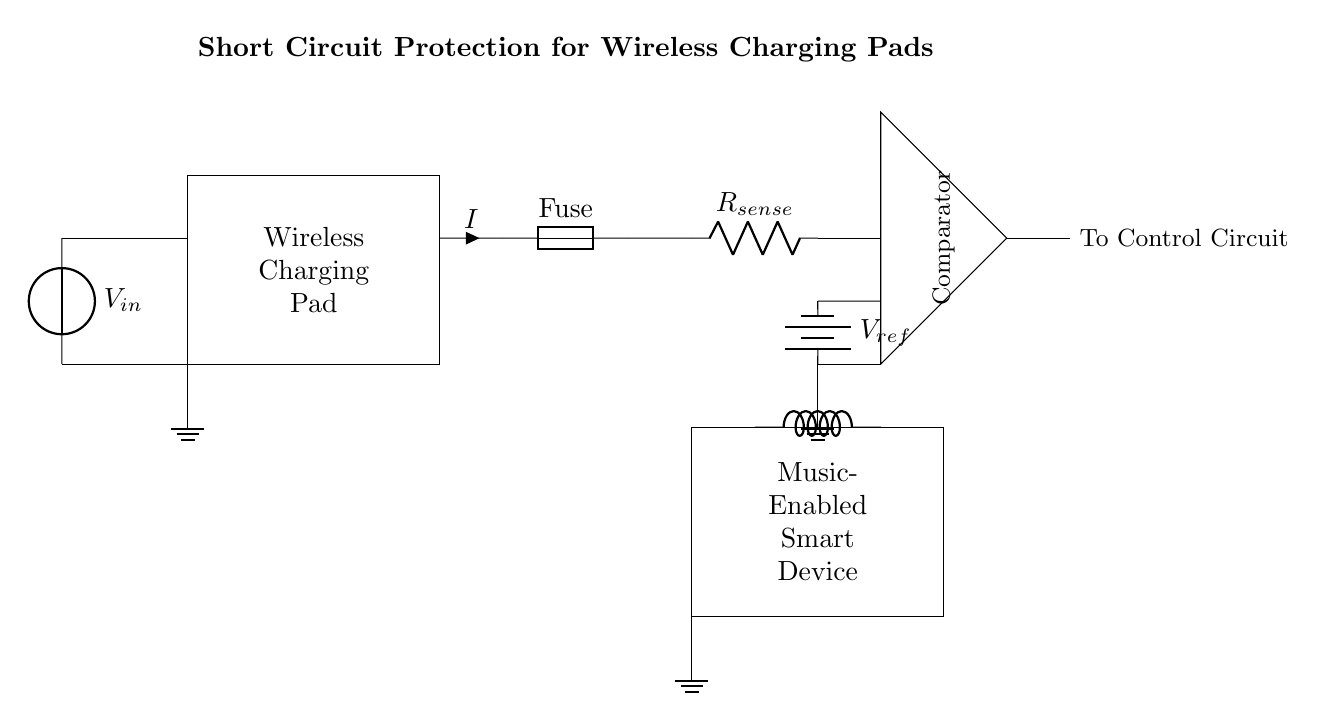What component is used for short circuit protection? The fuse is the component used specifically for short circuit protection, as indicated in the circuit diagram. It is placed in series with the current pathway to disconnect the circuit in case of excessive current.
Answer: Fuse What is the function of the resistor labeled R sense? The resistor labeled R sense is used to sense the current flowing through the circuit. It provides a voltage drop that can be measured to determine the current, allowing the comparator to monitor for overcurrent situations.
Answer: Current sensing What does the comparator do in this circuit? The comparator compares the voltage produced across the current sense resistor with a reference voltage to determine if the current exceeds a certain threshold, allowing it to activate protection measures if necessary.
Answer: Current monitoring What type of device is shown at the bottom of the circuit? The component shown at the bottom of the circuit is a music-enabled smart device, as labeled in the diagram. This indicates that it is likely the receiving device for power and data through the wireless charging pad.
Answer: Music-enabled smart device What is the reference voltage used for? The reference voltage, labeled V ref, is used by the comparator as a threshold to determine when the sensed current is too high, thus helping to trigger the short circuit protection mechanism.
Answer: Threshold for overcurrent What type of inductor is used in this circuit? The inductor used in this circuit is labeled as a cute inductor, which implies that it is specifically designed for wireless power transfer applications, efficient for the charging pad.
Answer: Cute inductor What happens if the current exceeds the threshold in this circuit? If the current exceeds the threshold, the comparator will trigger the fuse to blow or disconnect, effectively protecting the circuit from damage caused by the overcurrent condition.
Answer: Fuse disconnects 